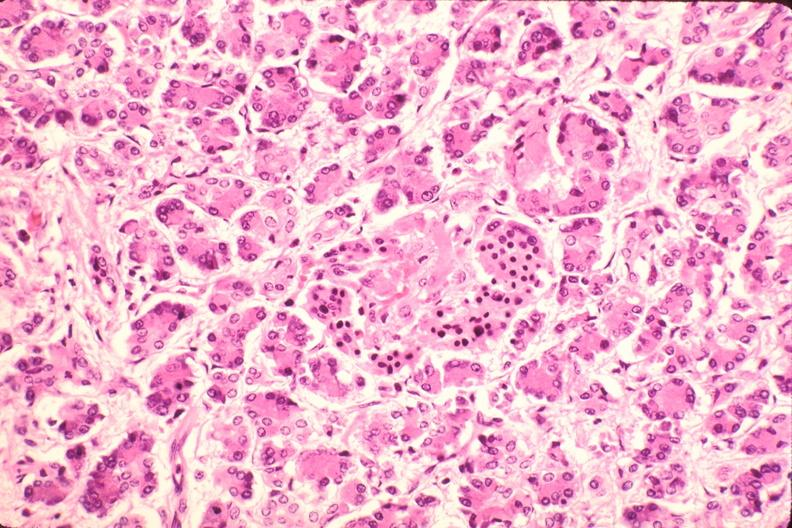what does this image show?
Answer the question using a single word or phrase. Pancreas 